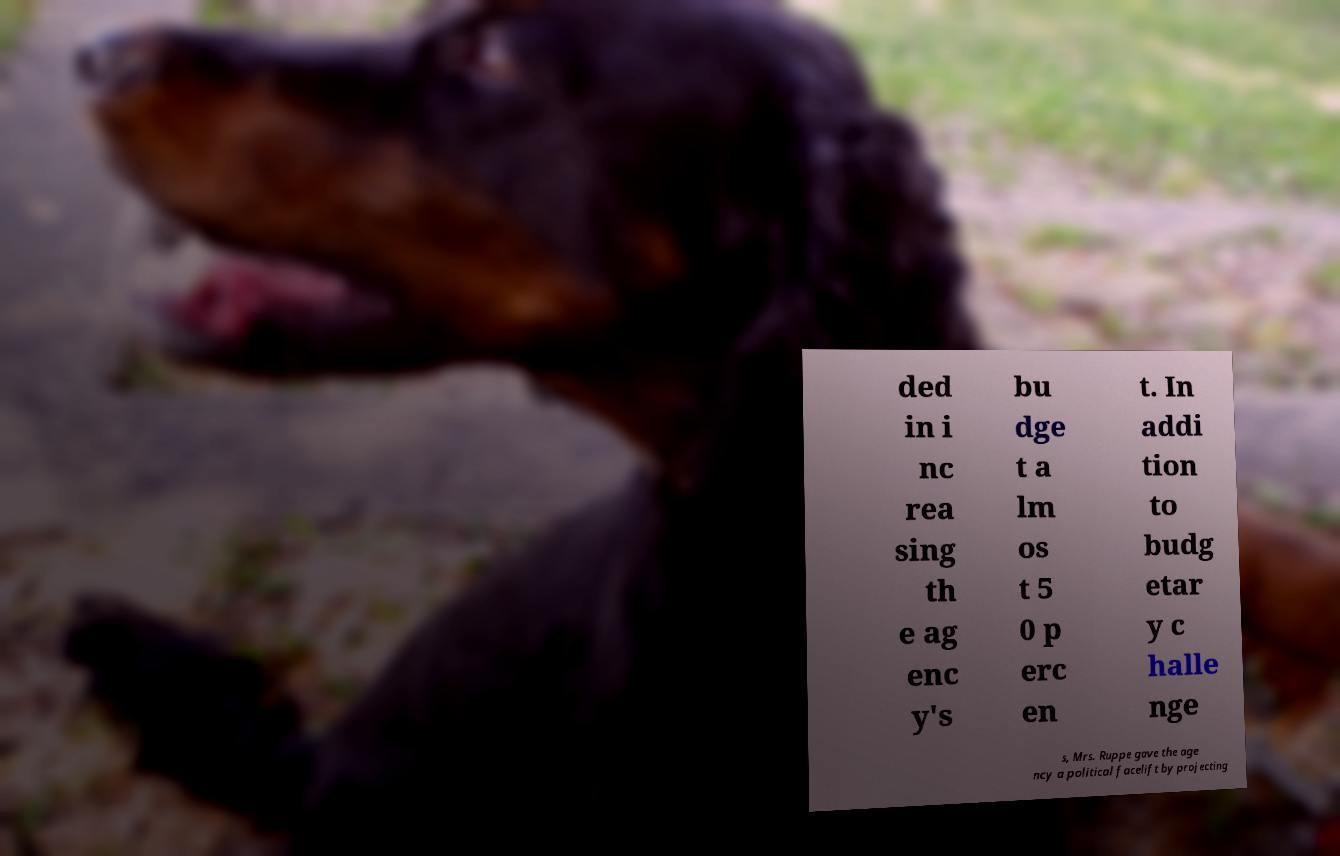Could you assist in decoding the text presented in this image and type it out clearly? ded in i nc rea sing th e ag enc y's bu dge t a lm os t 5 0 p erc en t. In addi tion to budg etar y c halle nge s, Mrs. Ruppe gave the age ncy a political facelift by projecting 